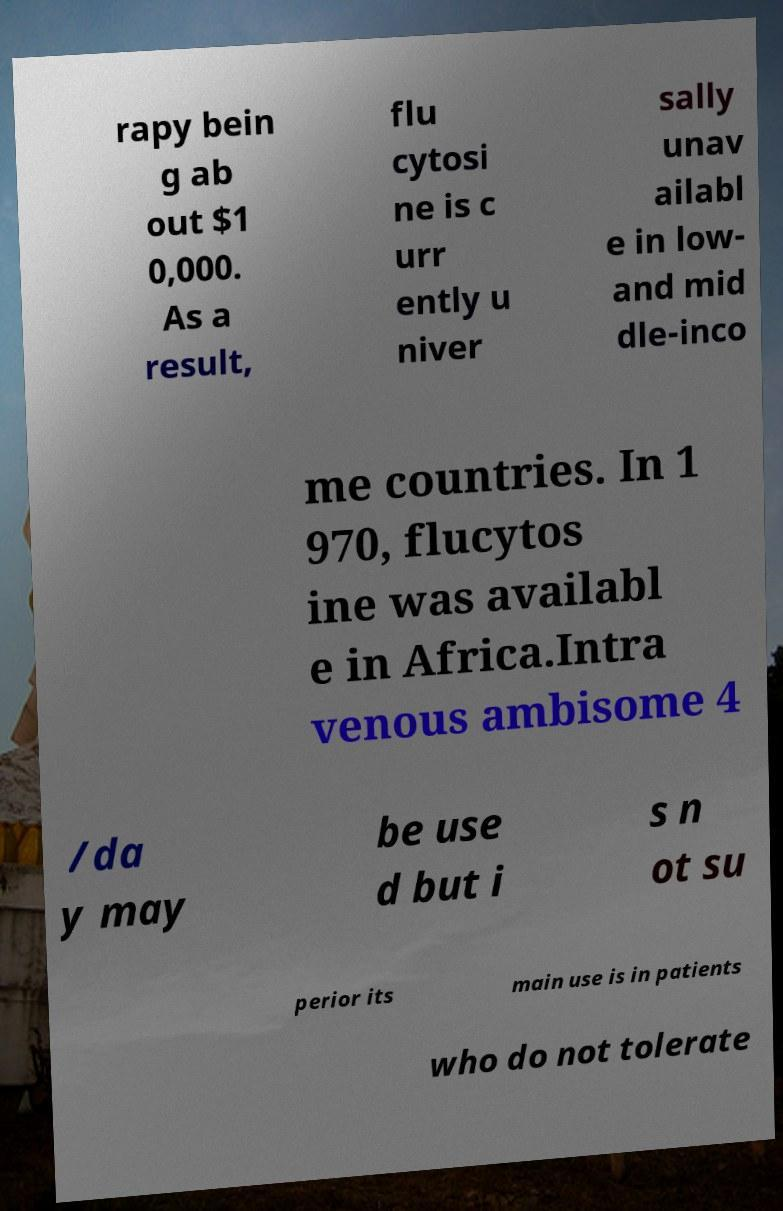For documentation purposes, I need the text within this image transcribed. Could you provide that? rapy bein g ab out $1 0,000. As a result, flu cytosi ne is c urr ently u niver sally unav ailabl e in low- and mid dle-inco me countries. In 1 970, flucytos ine was availabl e in Africa.Intra venous ambisome 4 /da y may be use d but i s n ot su perior its main use is in patients who do not tolerate 